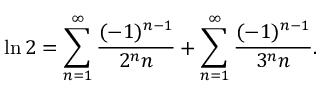Convert formula to latex. <formula><loc_0><loc_0><loc_500><loc_500>\ln 2 = \sum _ { n = 1 } ^ { \infty } { \frac { ( - 1 ) ^ { n - 1 } } { 2 ^ { n } n } } + \sum _ { n = 1 } ^ { \infty } { \frac { ( - 1 ) ^ { n - 1 } } { 3 ^ { n } n } } .</formula> 